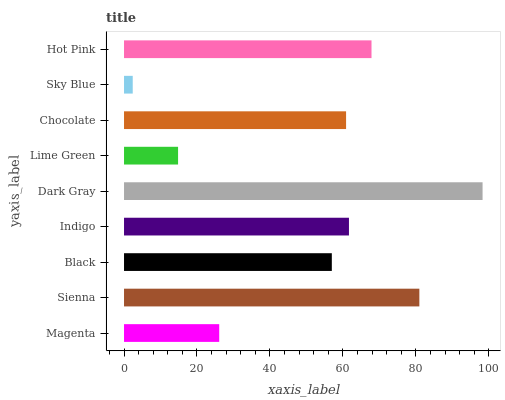Is Sky Blue the minimum?
Answer yes or no. Yes. Is Dark Gray the maximum?
Answer yes or no. Yes. Is Sienna the minimum?
Answer yes or no. No. Is Sienna the maximum?
Answer yes or no. No. Is Sienna greater than Magenta?
Answer yes or no. Yes. Is Magenta less than Sienna?
Answer yes or no. Yes. Is Magenta greater than Sienna?
Answer yes or no. No. Is Sienna less than Magenta?
Answer yes or no. No. Is Chocolate the high median?
Answer yes or no. Yes. Is Chocolate the low median?
Answer yes or no. Yes. Is Hot Pink the high median?
Answer yes or no. No. Is Magenta the low median?
Answer yes or no. No. 